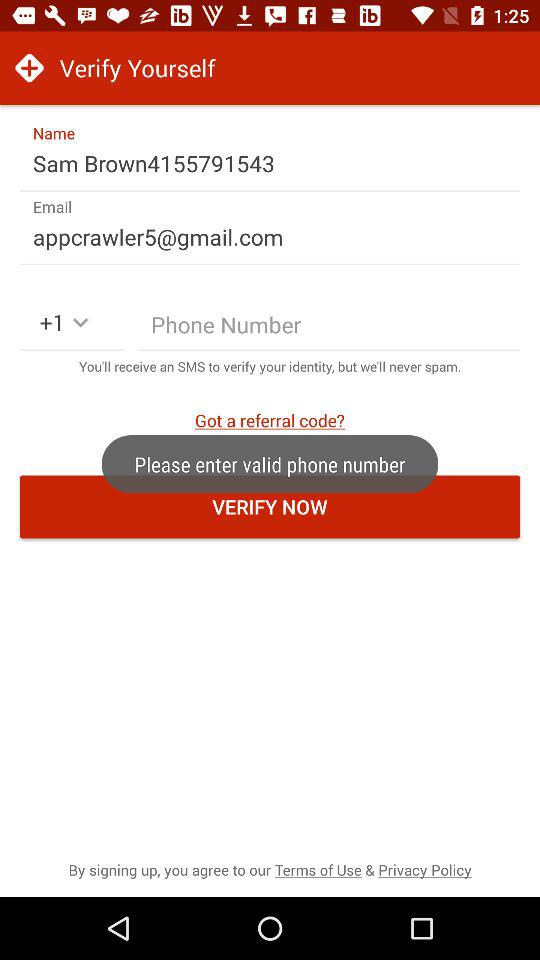What is the email address? The email address is appcrawler5@gmail.com. 